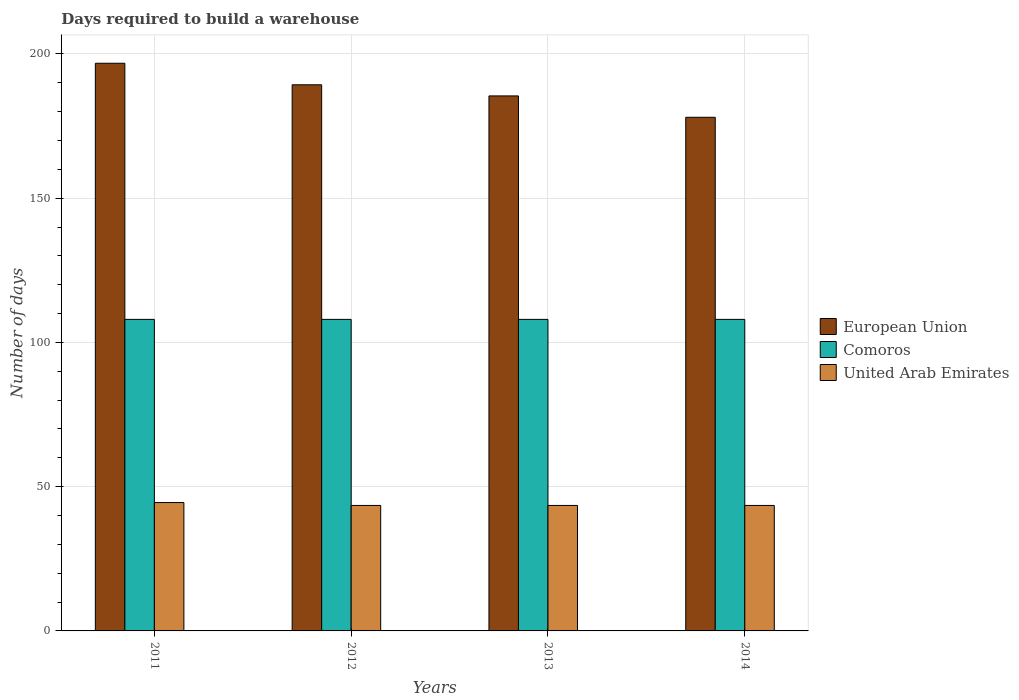Are the number of bars per tick equal to the number of legend labels?
Your answer should be compact. Yes. How many bars are there on the 3rd tick from the left?
Offer a terse response. 3. What is the label of the 4th group of bars from the left?
Offer a very short reply. 2014. In how many cases, is the number of bars for a given year not equal to the number of legend labels?
Give a very brief answer. 0. What is the days required to build a warehouse in in European Union in 2012?
Keep it short and to the point. 189.32. Across all years, what is the maximum days required to build a warehouse in in United Arab Emirates?
Your answer should be compact. 44.5. Across all years, what is the minimum days required to build a warehouse in in United Arab Emirates?
Provide a succinct answer. 43.5. In which year was the days required to build a warehouse in in United Arab Emirates minimum?
Give a very brief answer. 2012. What is the total days required to build a warehouse in in United Arab Emirates in the graph?
Your answer should be very brief. 175. What is the difference between the days required to build a warehouse in in Comoros in 2011 and the days required to build a warehouse in in United Arab Emirates in 2012?
Your answer should be compact. 64.5. What is the average days required to build a warehouse in in European Union per year?
Make the answer very short. 187.41. In the year 2011, what is the difference between the days required to build a warehouse in in United Arab Emirates and days required to build a warehouse in in Comoros?
Ensure brevity in your answer.  -63.5. What is the ratio of the days required to build a warehouse in in European Union in 2012 to that in 2014?
Your answer should be compact. 1.06. Is the days required to build a warehouse in in United Arab Emirates in 2012 less than that in 2013?
Keep it short and to the point. No. What is the difference between the highest and the lowest days required to build a warehouse in in Comoros?
Make the answer very short. 0. Is the sum of the days required to build a warehouse in in European Union in 2011 and 2013 greater than the maximum days required to build a warehouse in in United Arab Emirates across all years?
Offer a terse response. Yes. What does the 2nd bar from the left in 2011 represents?
Make the answer very short. Comoros. How many bars are there?
Keep it short and to the point. 12. Are all the bars in the graph horizontal?
Offer a terse response. No. How many years are there in the graph?
Keep it short and to the point. 4. What is the difference between two consecutive major ticks on the Y-axis?
Make the answer very short. 50. Are the values on the major ticks of Y-axis written in scientific E-notation?
Give a very brief answer. No. Does the graph contain any zero values?
Give a very brief answer. No. Does the graph contain grids?
Offer a very short reply. Yes. How many legend labels are there?
Provide a short and direct response. 3. What is the title of the graph?
Keep it short and to the point. Days required to build a warehouse. What is the label or title of the X-axis?
Provide a succinct answer. Years. What is the label or title of the Y-axis?
Provide a short and direct response. Number of days. What is the Number of days in European Union in 2011?
Give a very brief answer. 196.79. What is the Number of days in Comoros in 2011?
Your answer should be very brief. 108. What is the Number of days in United Arab Emirates in 2011?
Give a very brief answer. 44.5. What is the Number of days of European Union in 2012?
Give a very brief answer. 189.32. What is the Number of days in Comoros in 2012?
Provide a succinct answer. 108. What is the Number of days in United Arab Emirates in 2012?
Provide a succinct answer. 43.5. What is the Number of days in European Union in 2013?
Your answer should be compact. 185.46. What is the Number of days in Comoros in 2013?
Your answer should be compact. 108. What is the Number of days of United Arab Emirates in 2013?
Make the answer very short. 43.5. What is the Number of days in European Union in 2014?
Give a very brief answer. 178.05. What is the Number of days of Comoros in 2014?
Your response must be concise. 108. What is the Number of days of United Arab Emirates in 2014?
Make the answer very short. 43.5. Across all years, what is the maximum Number of days in European Union?
Make the answer very short. 196.79. Across all years, what is the maximum Number of days of Comoros?
Your answer should be very brief. 108. Across all years, what is the maximum Number of days of United Arab Emirates?
Your answer should be very brief. 44.5. Across all years, what is the minimum Number of days in European Union?
Offer a very short reply. 178.05. Across all years, what is the minimum Number of days of Comoros?
Keep it short and to the point. 108. Across all years, what is the minimum Number of days in United Arab Emirates?
Your answer should be compact. 43.5. What is the total Number of days in European Union in the graph?
Your response must be concise. 749.62. What is the total Number of days of Comoros in the graph?
Ensure brevity in your answer.  432. What is the total Number of days of United Arab Emirates in the graph?
Give a very brief answer. 175. What is the difference between the Number of days of European Union in 2011 and that in 2012?
Make the answer very short. 7.46. What is the difference between the Number of days of Comoros in 2011 and that in 2012?
Your response must be concise. 0. What is the difference between the Number of days of European Union in 2011 and that in 2013?
Your answer should be very brief. 11.32. What is the difference between the Number of days in United Arab Emirates in 2011 and that in 2013?
Your response must be concise. 1. What is the difference between the Number of days of European Union in 2011 and that in 2014?
Your answer should be very brief. 18.73. What is the difference between the Number of days of European Union in 2012 and that in 2013?
Offer a very short reply. 3.86. What is the difference between the Number of days in Comoros in 2012 and that in 2013?
Your response must be concise. 0. What is the difference between the Number of days in European Union in 2012 and that in 2014?
Offer a terse response. 11.27. What is the difference between the Number of days in United Arab Emirates in 2012 and that in 2014?
Offer a terse response. 0. What is the difference between the Number of days in European Union in 2013 and that in 2014?
Your answer should be very brief. 7.41. What is the difference between the Number of days in Comoros in 2013 and that in 2014?
Provide a short and direct response. 0. What is the difference between the Number of days in European Union in 2011 and the Number of days in Comoros in 2012?
Provide a succinct answer. 88.79. What is the difference between the Number of days in European Union in 2011 and the Number of days in United Arab Emirates in 2012?
Offer a very short reply. 153.29. What is the difference between the Number of days in Comoros in 2011 and the Number of days in United Arab Emirates in 2012?
Your answer should be compact. 64.5. What is the difference between the Number of days in European Union in 2011 and the Number of days in Comoros in 2013?
Offer a terse response. 88.79. What is the difference between the Number of days of European Union in 2011 and the Number of days of United Arab Emirates in 2013?
Your response must be concise. 153.29. What is the difference between the Number of days in Comoros in 2011 and the Number of days in United Arab Emirates in 2013?
Offer a very short reply. 64.5. What is the difference between the Number of days of European Union in 2011 and the Number of days of Comoros in 2014?
Provide a short and direct response. 88.79. What is the difference between the Number of days in European Union in 2011 and the Number of days in United Arab Emirates in 2014?
Your answer should be very brief. 153.29. What is the difference between the Number of days of Comoros in 2011 and the Number of days of United Arab Emirates in 2014?
Offer a terse response. 64.5. What is the difference between the Number of days of European Union in 2012 and the Number of days of Comoros in 2013?
Ensure brevity in your answer.  81.32. What is the difference between the Number of days of European Union in 2012 and the Number of days of United Arab Emirates in 2013?
Offer a terse response. 145.82. What is the difference between the Number of days of Comoros in 2012 and the Number of days of United Arab Emirates in 2013?
Give a very brief answer. 64.5. What is the difference between the Number of days in European Union in 2012 and the Number of days in Comoros in 2014?
Your answer should be very brief. 81.32. What is the difference between the Number of days in European Union in 2012 and the Number of days in United Arab Emirates in 2014?
Your answer should be compact. 145.82. What is the difference between the Number of days of Comoros in 2012 and the Number of days of United Arab Emirates in 2014?
Keep it short and to the point. 64.5. What is the difference between the Number of days in European Union in 2013 and the Number of days in Comoros in 2014?
Provide a succinct answer. 77.46. What is the difference between the Number of days in European Union in 2013 and the Number of days in United Arab Emirates in 2014?
Offer a terse response. 141.96. What is the difference between the Number of days in Comoros in 2013 and the Number of days in United Arab Emirates in 2014?
Provide a succinct answer. 64.5. What is the average Number of days in European Union per year?
Your answer should be compact. 187.41. What is the average Number of days in Comoros per year?
Your response must be concise. 108. What is the average Number of days of United Arab Emirates per year?
Your response must be concise. 43.75. In the year 2011, what is the difference between the Number of days of European Union and Number of days of Comoros?
Your answer should be compact. 88.79. In the year 2011, what is the difference between the Number of days in European Union and Number of days in United Arab Emirates?
Your response must be concise. 152.29. In the year 2011, what is the difference between the Number of days of Comoros and Number of days of United Arab Emirates?
Your answer should be very brief. 63.5. In the year 2012, what is the difference between the Number of days in European Union and Number of days in Comoros?
Ensure brevity in your answer.  81.32. In the year 2012, what is the difference between the Number of days of European Union and Number of days of United Arab Emirates?
Provide a succinct answer. 145.82. In the year 2012, what is the difference between the Number of days of Comoros and Number of days of United Arab Emirates?
Make the answer very short. 64.5. In the year 2013, what is the difference between the Number of days of European Union and Number of days of Comoros?
Provide a short and direct response. 77.46. In the year 2013, what is the difference between the Number of days of European Union and Number of days of United Arab Emirates?
Make the answer very short. 141.96. In the year 2013, what is the difference between the Number of days in Comoros and Number of days in United Arab Emirates?
Offer a very short reply. 64.5. In the year 2014, what is the difference between the Number of days in European Union and Number of days in Comoros?
Offer a terse response. 70.05. In the year 2014, what is the difference between the Number of days in European Union and Number of days in United Arab Emirates?
Offer a very short reply. 134.55. In the year 2014, what is the difference between the Number of days of Comoros and Number of days of United Arab Emirates?
Make the answer very short. 64.5. What is the ratio of the Number of days in European Union in 2011 to that in 2012?
Offer a very short reply. 1.04. What is the ratio of the Number of days in European Union in 2011 to that in 2013?
Your answer should be compact. 1.06. What is the ratio of the Number of days in Comoros in 2011 to that in 2013?
Offer a terse response. 1. What is the ratio of the Number of days in European Union in 2011 to that in 2014?
Your response must be concise. 1.11. What is the ratio of the Number of days in United Arab Emirates in 2011 to that in 2014?
Offer a very short reply. 1.02. What is the ratio of the Number of days of European Union in 2012 to that in 2013?
Ensure brevity in your answer.  1.02. What is the ratio of the Number of days of European Union in 2012 to that in 2014?
Provide a succinct answer. 1.06. What is the ratio of the Number of days of Comoros in 2012 to that in 2014?
Give a very brief answer. 1. What is the ratio of the Number of days in United Arab Emirates in 2012 to that in 2014?
Keep it short and to the point. 1. What is the ratio of the Number of days in European Union in 2013 to that in 2014?
Your answer should be compact. 1.04. What is the difference between the highest and the second highest Number of days in European Union?
Your answer should be compact. 7.46. What is the difference between the highest and the lowest Number of days in European Union?
Your response must be concise. 18.73. 